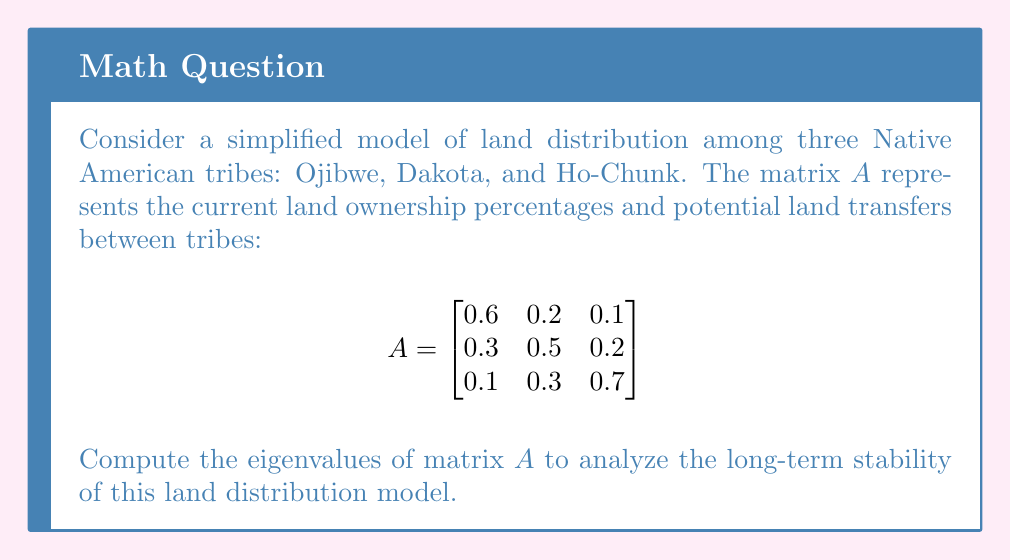Help me with this question. To find the eigenvalues of matrix $A$, we need to solve the characteristic equation:

1) First, we set up the equation $det(A - \lambda I) = 0$, where $I$ is the 3x3 identity matrix:

   $$det\begin{pmatrix}
   0.6-\lambda & 0.2 & 0.1 \\
   0.3 & 0.5-\lambda & 0.2 \\
   0.1 & 0.3 & 0.7-\lambda
   \end{pmatrix} = 0$$

2) Expanding the determinant:
   
   $(0.6-\lambda)[(0.5-\lambda)(0.7-\lambda) - 0.06] - 0.2[0.3(0.7-\lambda) - 0.02] + 0.1[0.3(0.5-\lambda) - 0.06] = 0$

3) Simplifying:
   
   $(0.6-\lambda)(0.35-1.2\lambda+\lambda^2) - 0.2(0.21-0.3\lambda) + 0.1(0.15-0.3\lambda) = 0$

4) Expanding further:
   
   $0.21 - 0.72\lambda + 0.6\lambda^2 - 0.35\lambda + 1.2\lambda^2 - \lambda^3 - 0.042 + 0.06\lambda + 0.015 - 0.03\lambda = 0$

5) Combining like terms:
   
   $-\lambda^3 + 1.8\lambda^2 - 1.09\lambda + 0.183 = 0$

6) This is a cubic equation. We can solve it using the cubic formula or numerical methods. Using a computer algebra system, we find the roots:

   $\lambda_1 \approx 1$
   $\lambda_2 \approx 0.5$
   $\lambda_3 \approx 0.3$

These are the eigenvalues of matrix $A$.
Answer: $\lambda_1 \approx 1$, $\lambda_2 \approx 0.5$, $\lambda_3 \approx 0.3$ 